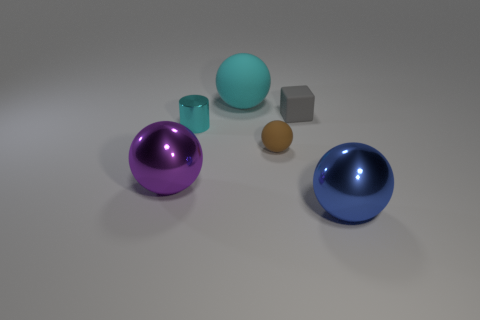Subtract all tiny rubber balls. How many balls are left? 3 Subtract all purple balls. How many balls are left? 3 Subtract 1 cylinders. How many cylinders are left? 0 Add 3 brown rubber spheres. How many objects exist? 9 Subtract all blocks. How many objects are left? 5 Subtract all red blocks. Subtract all green spheres. How many blocks are left? 1 Subtract all brown things. Subtract all cyan cylinders. How many objects are left? 4 Add 3 big purple balls. How many big purple balls are left? 4 Add 6 large matte spheres. How many large matte spheres exist? 7 Subtract 0 brown cylinders. How many objects are left? 6 